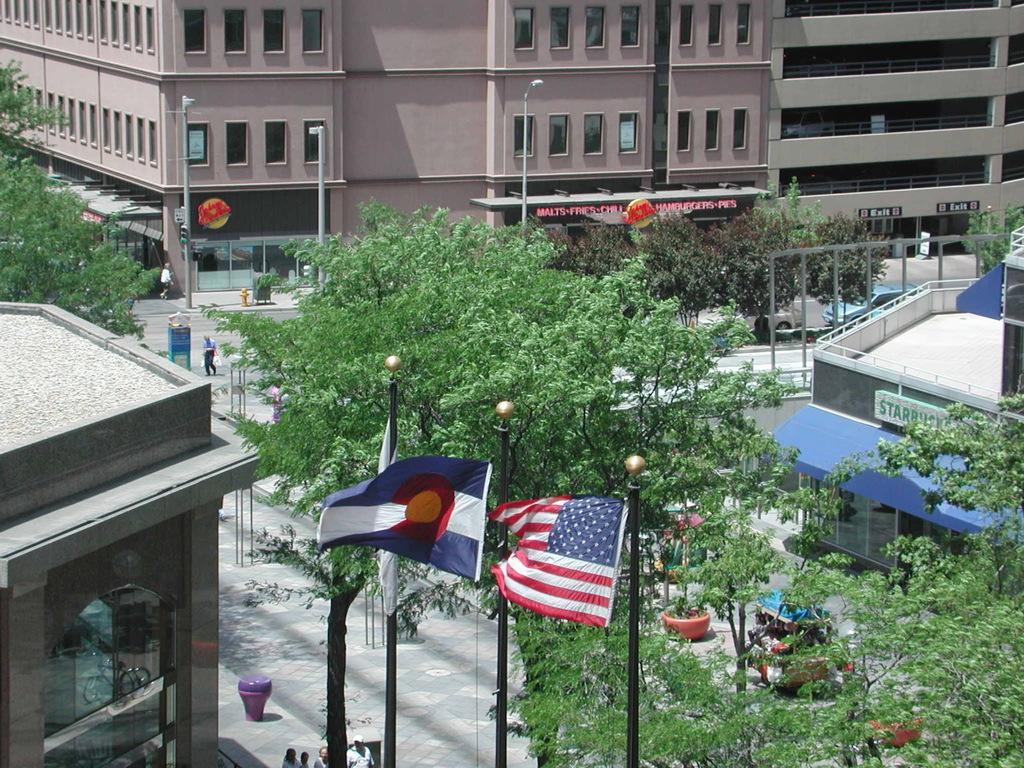Could you give a brief overview of what you see in this image? In this picture we can see buildings. Here we can see some peoples are standing near to the road. In the center we can see many trees. Here we can see street lights, poles and flags. 